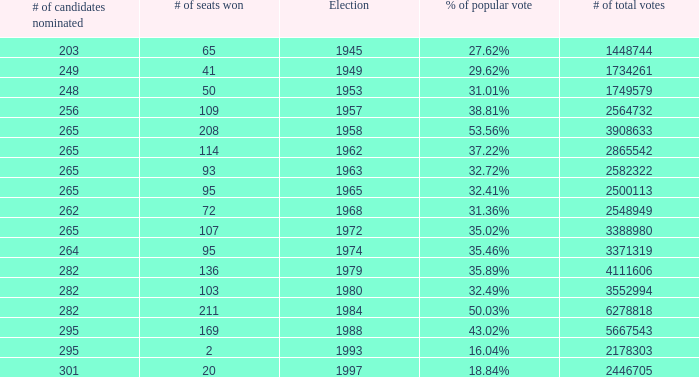What year was the election when the # of seats won was 65? 1945.0. 